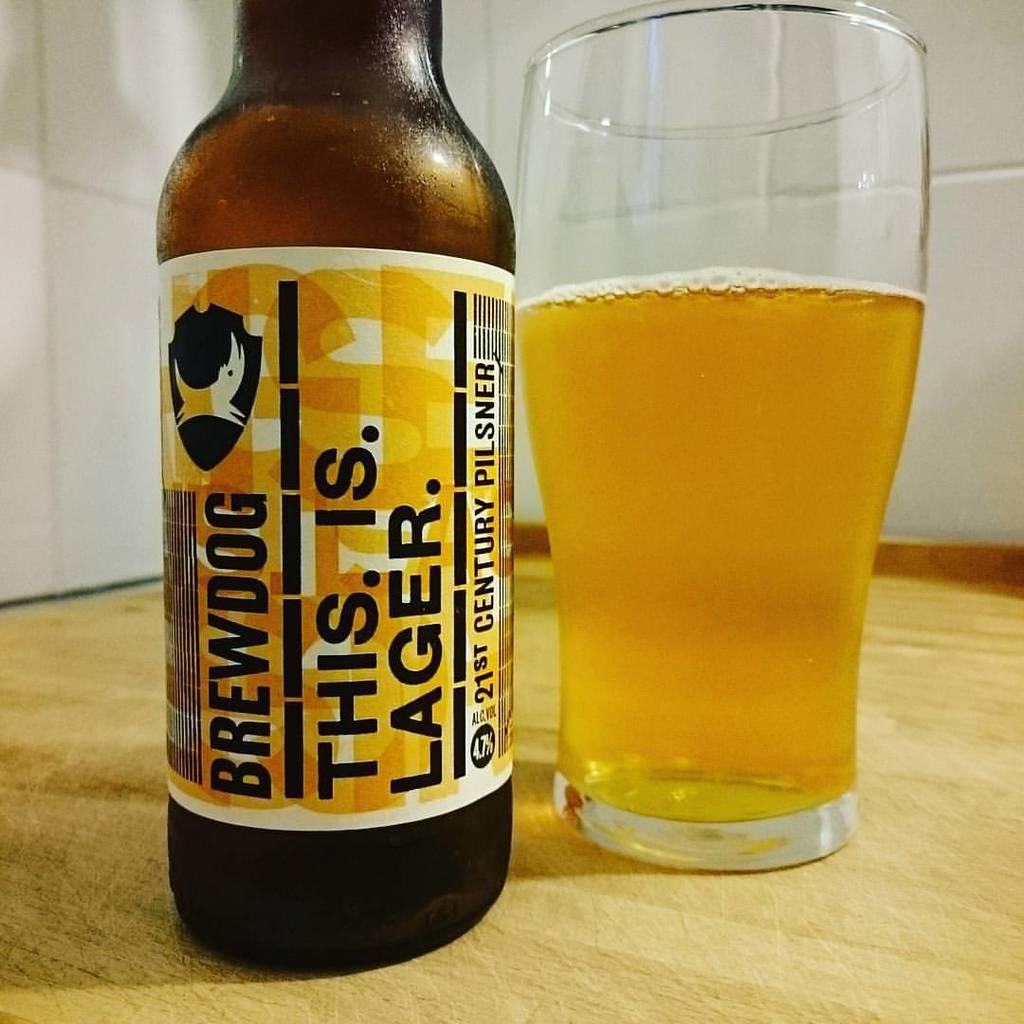What is the company name?
Make the answer very short. Brewdog. 